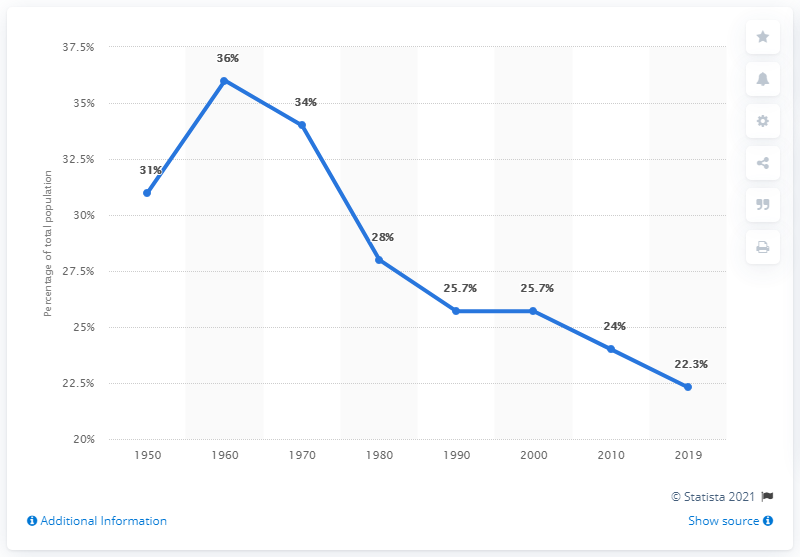Point out several critical features in this image. In 2019, approximately 22.3% of the population of the United States was comprised of children. 